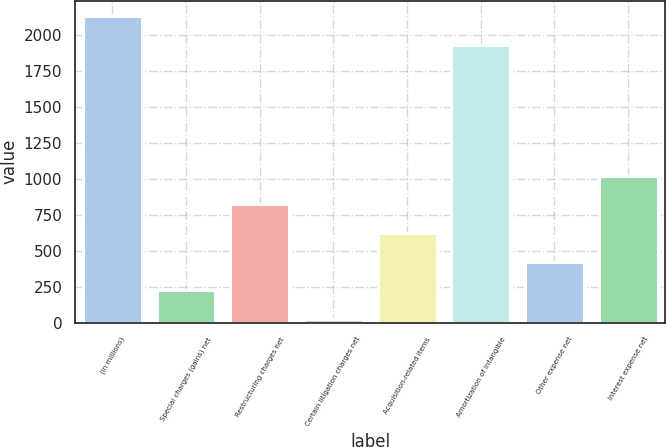Convert chart. <chart><loc_0><loc_0><loc_500><loc_500><bar_chart><fcel>(in millions)<fcel>Special charges (gains) net<fcel>Restructuring charges net<fcel>Certain litigation charges net<fcel>Acquisition-related items<fcel>Amortization of intangible<fcel>Other expense net<fcel>Interest expense net<nl><fcel>2130<fcel>225<fcel>822<fcel>26<fcel>623<fcel>1931<fcel>424<fcel>1021<nl></chart> 